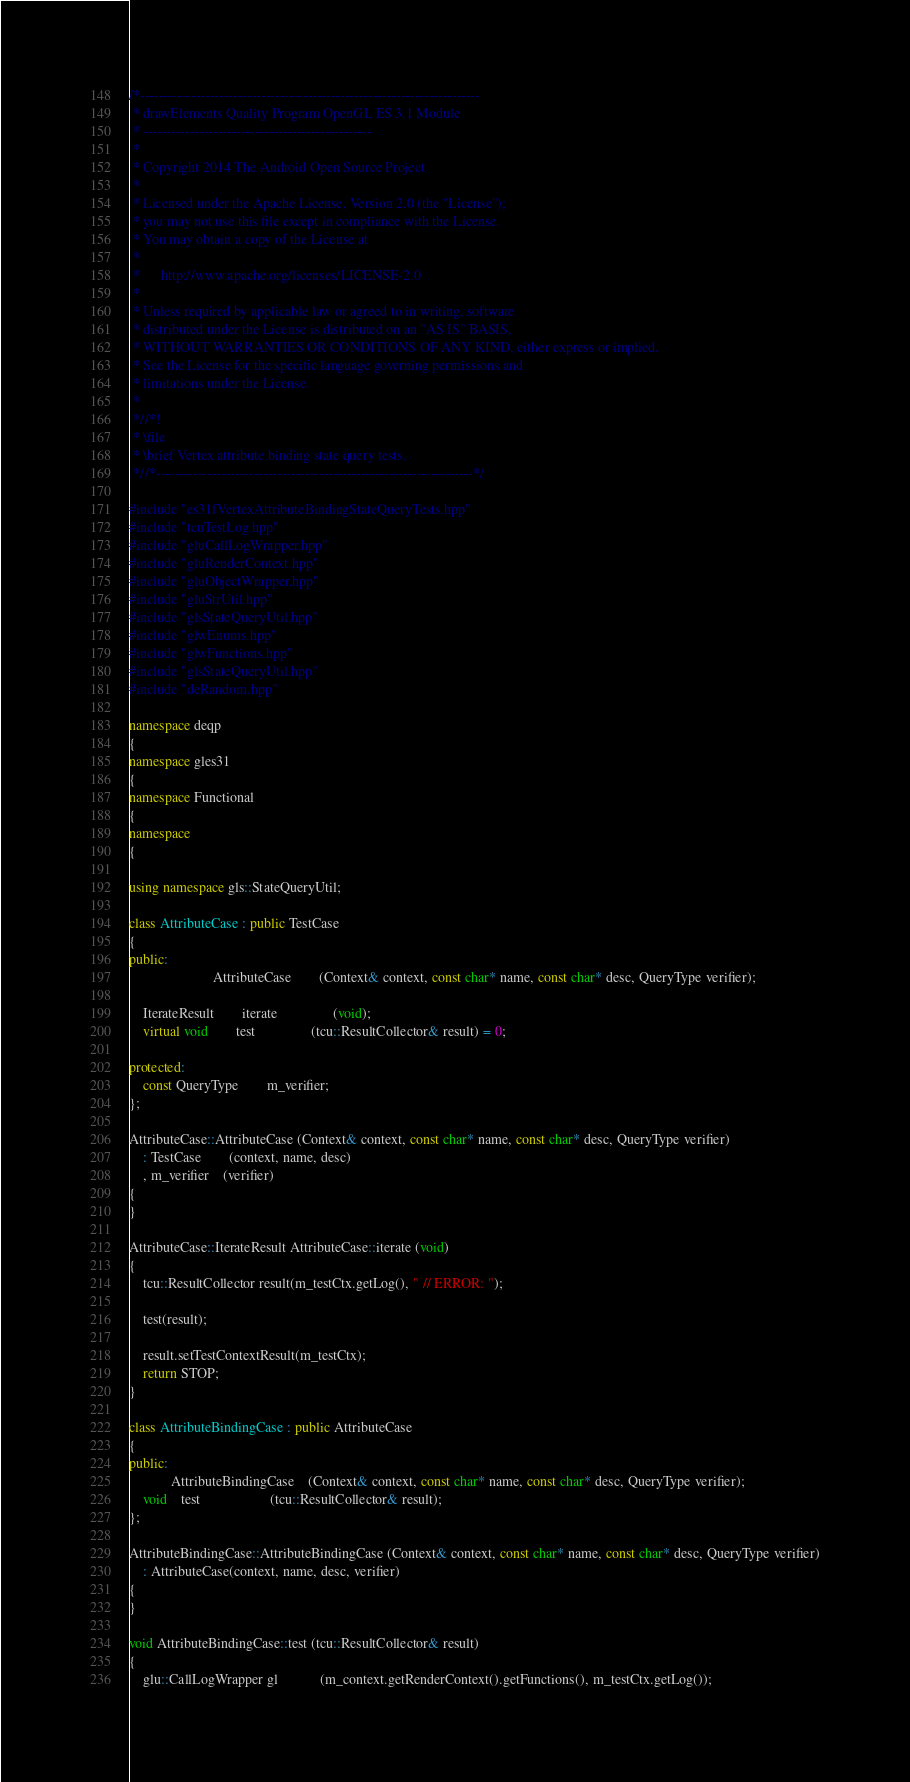Convert code to text. <code><loc_0><loc_0><loc_500><loc_500><_C++_>/*-------------------------------------------------------------------------
 * drawElements Quality Program OpenGL ES 3.1 Module
 * -------------------------------------------------
 *
 * Copyright 2014 The Android Open Source Project
 *
 * Licensed under the Apache License, Version 2.0 (the "License");
 * you may not use this file except in compliance with the License.
 * You may obtain a copy of the License at
 *
 *      http://www.apache.org/licenses/LICENSE-2.0
 *
 * Unless required by applicable law or agreed to in writing, software
 * distributed under the License is distributed on an "AS IS" BASIS,
 * WITHOUT WARRANTIES OR CONDITIONS OF ANY KIND, either express or implied.
 * See the License for the specific language governing permissions and
 * limitations under the License.
 *
 *//*!
 * \file
 * \brief Vertex attribute binding state query tests.
 *//*--------------------------------------------------------------------*/

#include "es31fVertexAttributeBindingStateQueryTests.hpp"
#include "tcuTestLog.hpp"
#include "gluCallLogWrapper.hpp"
#include "gluRenderContext.hpp"
#include "gluObjectWrapper.hpp"
#include "gluStrUtil.hpp"
#include "glsStateQueryUtil.hpp"
#include "glwEnums.hpp"
#include "glwFunctions.hpp"
#include "glsStateQueryUtil.hpp"
#include "deRandom.hpp"

namespace deqp
{
namespace gles31
{
namespace Functional
{
namespace
{

using namespace gls::StateQueryUtil;

class AttributeCase : public TestCase
{
public:
						AttributeCase		(Context& context, const char* name, const char* desc, QueryType verifier);

	IterateResult		iterate				(void);
	virtual void		test				(tcu::ResultCollector& result) = 0;

protected:
	const QueryType		m_verifier;
};

AttributeCase::AttributeCase (Context& context, const char* name, const char* desc, QueryType verifier)
	: TestCase		(context, name, desc)
	, m_verifier	(verifier)
{
}

AttributeCase::IterateResult AttributeCase::iterate (void)
{
	tcu::ResultCollector result(m_testCtx.getLog(), " // ERROR: ");

	test(result);

	result.setTestContextResult(m_testCtx);
	return STOP;
}

class AttributeBindingCase : public AttributeCase
{
public:
			AttributeBindingCase	(Context& context, const char* name, const char* desc, QueryType verifier);
	void	test					(tcu::ResultCollector& result);
};

AttributeBindingCase::AttributeBindingCase (Context& context, const char* name, const char* desc, QueryType verifier)
	: AttributeCase(context, name, desc, verifier)
{
}

void AttributeBindingCase::test (tcu::ResultCollector& result)
{
	glu::CallLogWrapper gl			(m_context.getRenderContext().getFunctions(), m_testCtx.getLog());</code> 